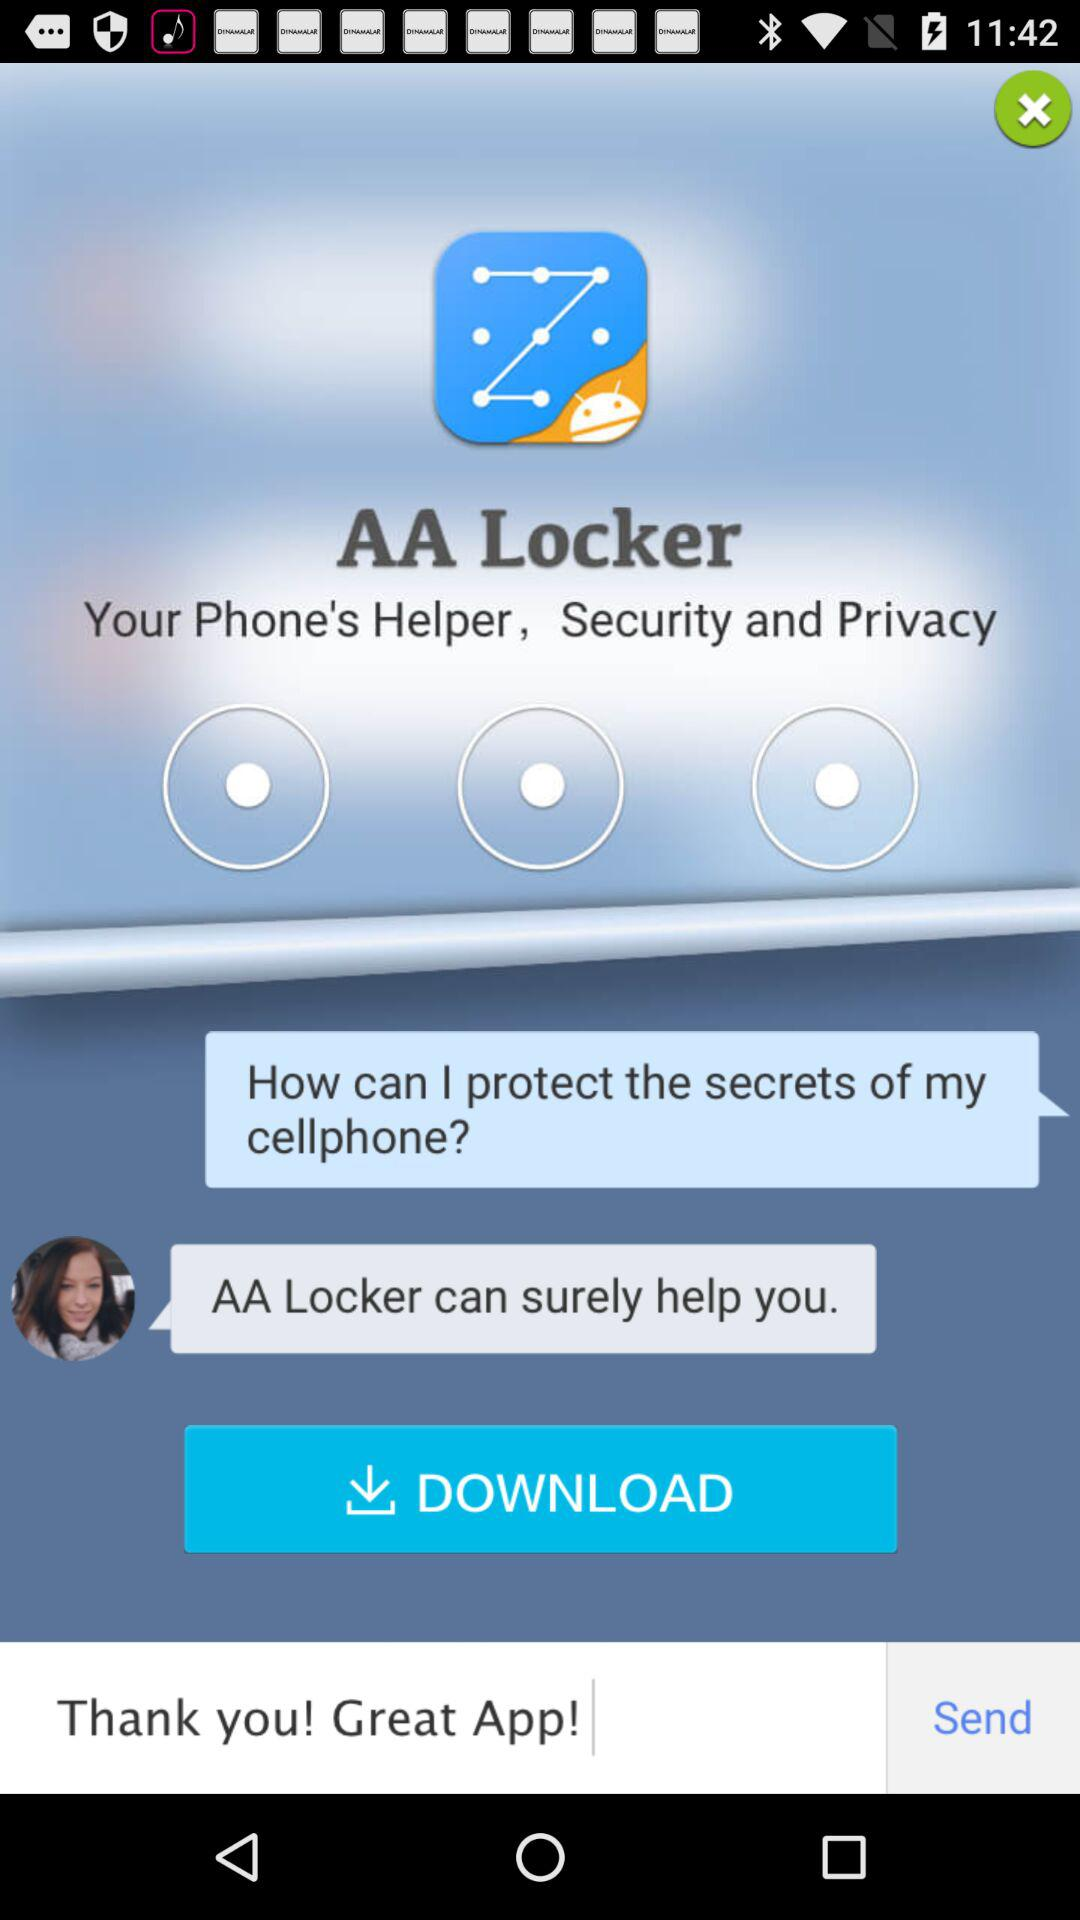What is the app name? The app name is "AA Locker". 